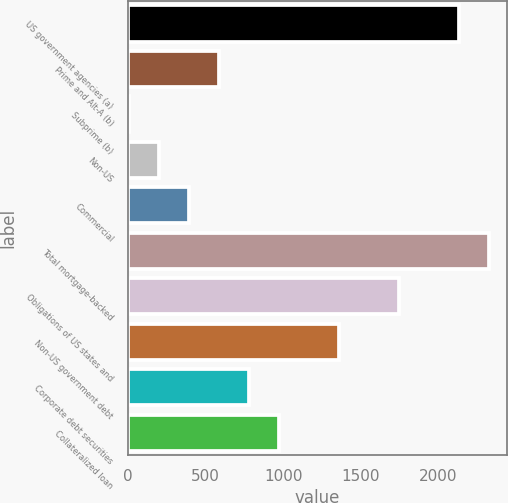<chart> <loc_0><loc_0><loc_500><loc_500><bar_chart><fcel>US government agencies (a)<fcel>Prime and Alt-A (b)<fcel>Subprime (b)<fcel>Non-US<fcel>Commercial<fcel>Total mortgage-backed<fcel>Obligations of US states and<fcel>Non-US government debt<fcel>Corporate debt securities<fcel>Collateralized loan<nl><fcel>2131.2<fcel>585.6<fcel>6<fcel>199.2<fcel>392.4<fcel>2324.4<fcel>1744.8<fcel>1358.4<fcel>778.8<fcel>972<nl></chart> 